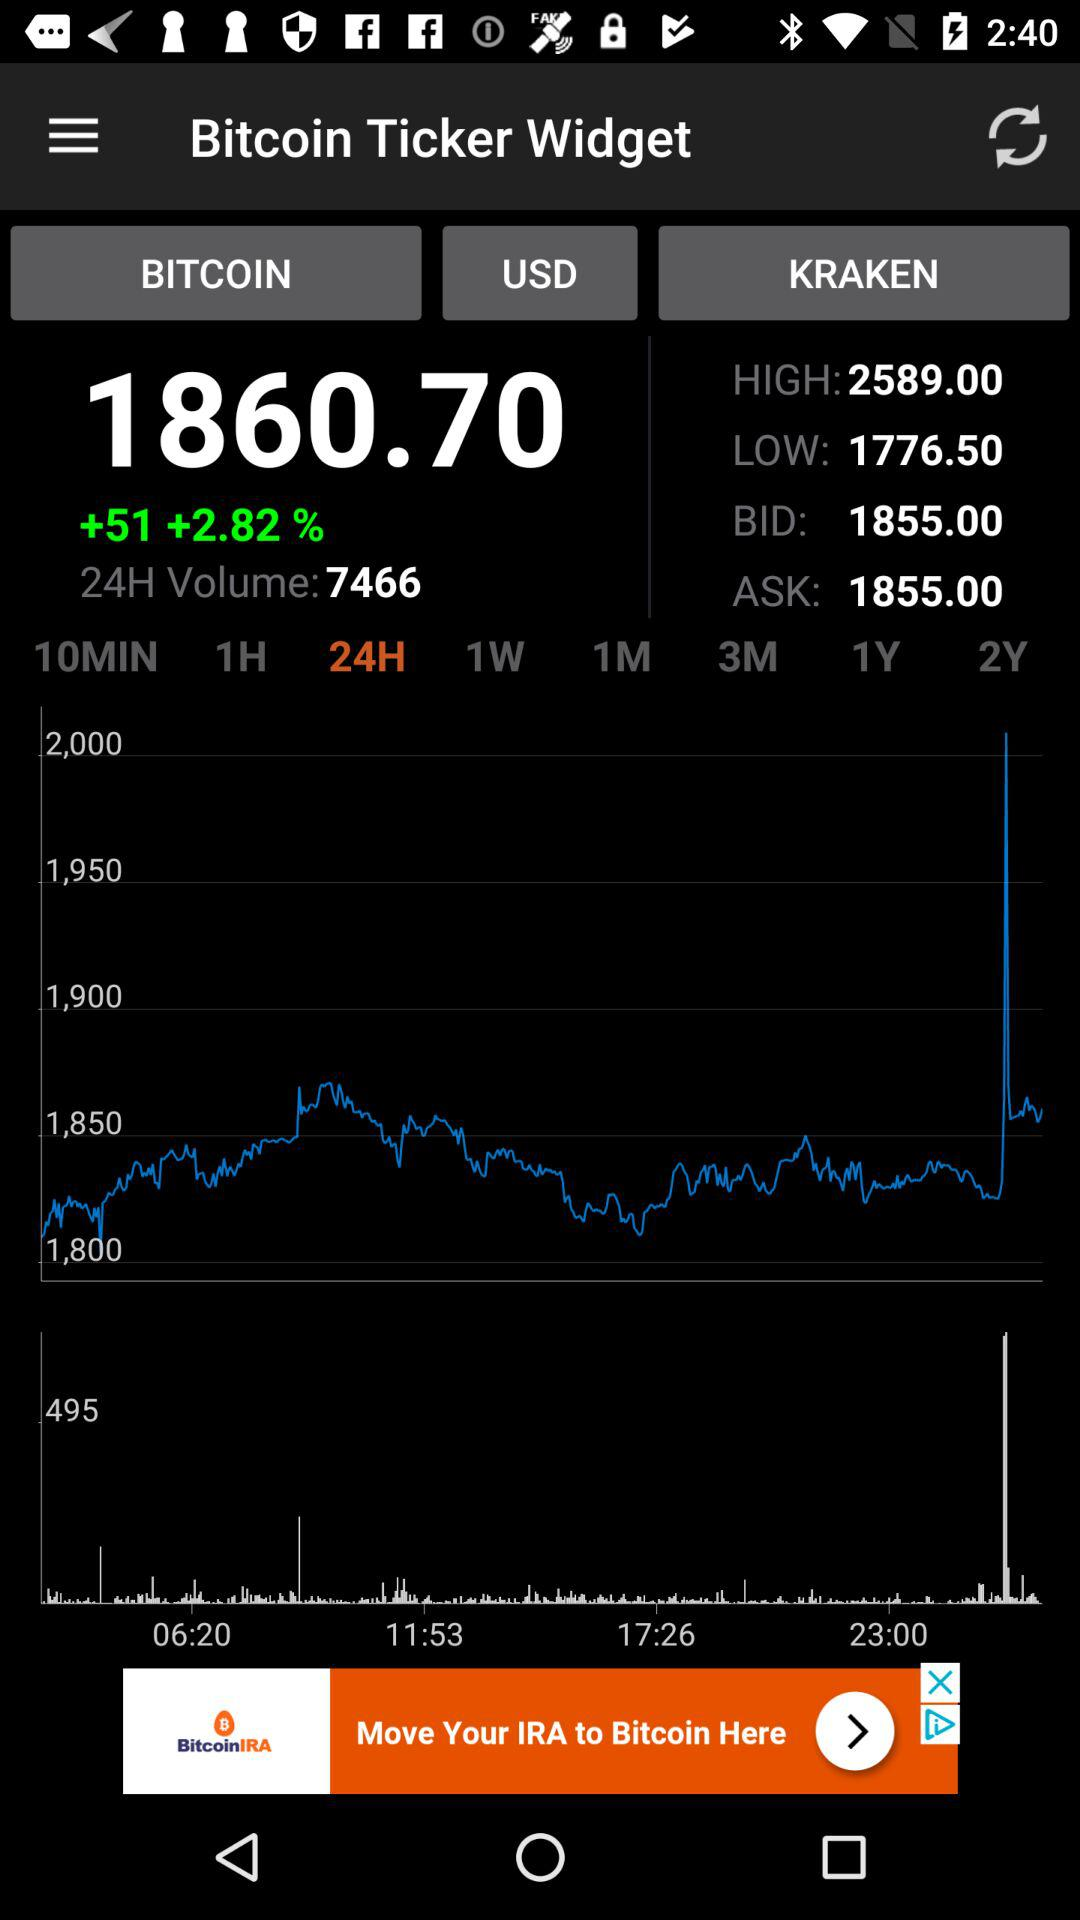What is 24H volume? The 24H volume is 7466. 